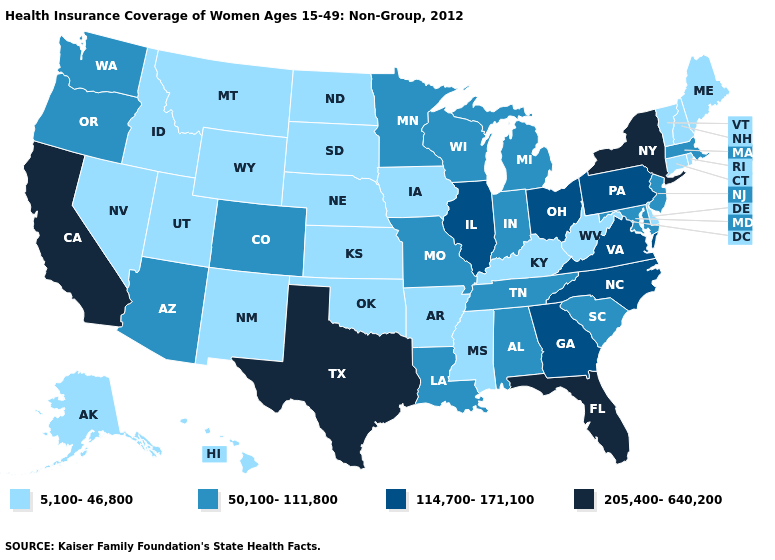Does the first symbol in the legend represent the smallest category?
Answer briefly. Yes. Among the states that border Washington , which have the lowest value?
Short answer required. Idaho. What is the lowest value in the USA?
Give a very brief answer. 5,100-46,800. What is the value of Wyoming?
Keep it brief. 5,100-46,800. What is the lowest value in the South?
Be succinct. 5,100-46,800. Which states have the highest value in the USA?
Answer briefly. California, Florida, New York, Texas. What is the value of Florida?
Keep it brief. 205,400-640,200. Does Georgia have a higher value than Ohio?
Quick response, please. No. What is the value of Missouri?
Keep it brief. 50,100-111,800. Does New York have a higher value than Georgia?
Concise answer only. Yes. Is the legend a continuous bar?
Keep it brief. No. Does Texas have the same value as Alaska?
Write a very short answer. No. Does the map have missing data?
Be succinct. No. What is the highest value in the USA?
Short answer required. 205,400-640,200. 